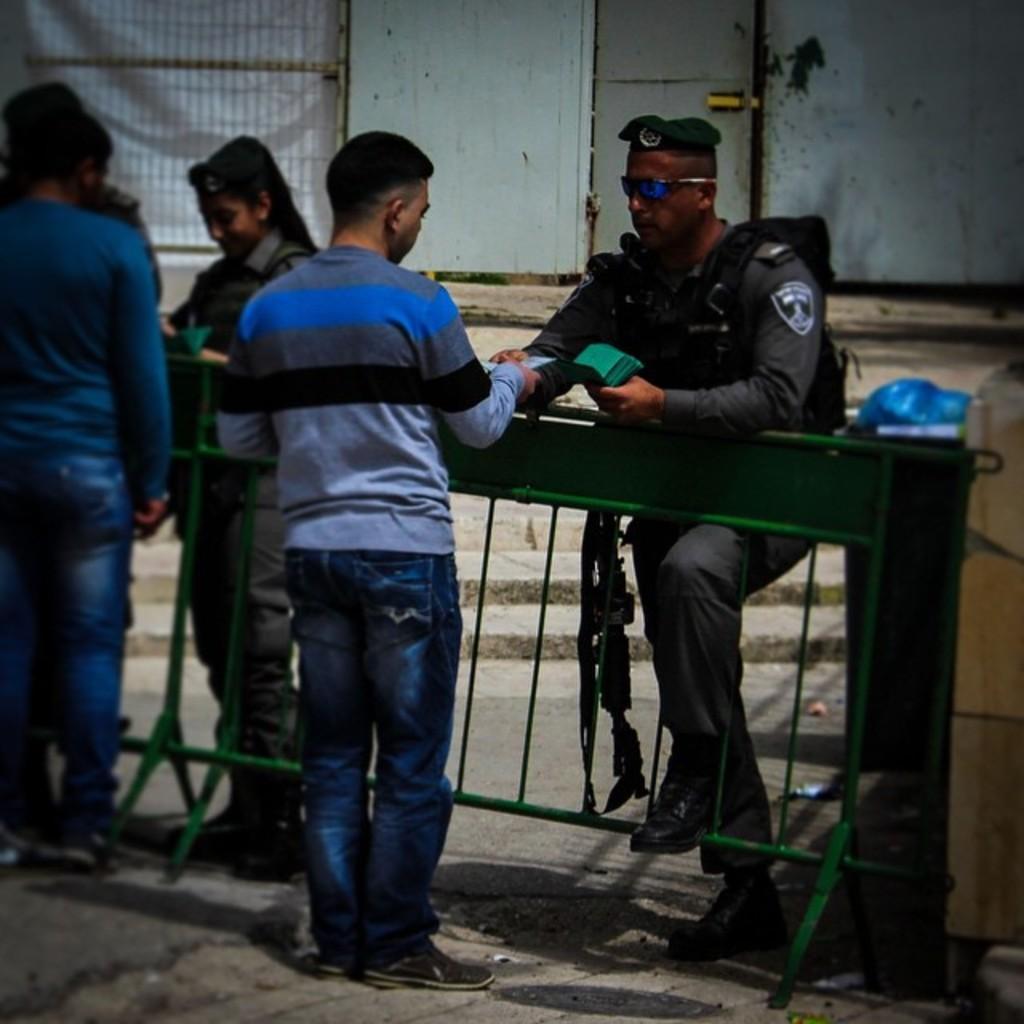Can you describe this image briefly? On the left side, there are two persons standing in front of a fence. One of them is holding a card. Outside this fence, there is a fence in uniform, wearing a bag and placing a hand on this fence and there is a woman standing. In the background, there are steps and a wall having a door and a fence. 